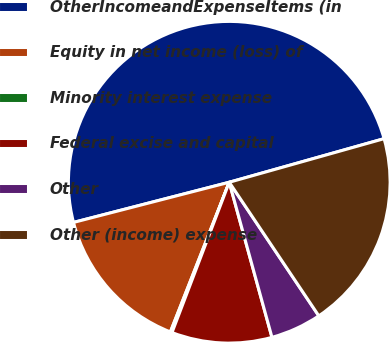<chart> <loc_0><loc_0><loc_500><loc_500><pie_chart><fcel>OtherIncomeandExpenseItems (in<fcel>Equity in net income (loss) of<fcel>Minority interest expense<fcel>Federal excise and capital<fcel>Other<fcel>Other (income) expense<nl><fcel>49.65%<fcel>15.02%<fcel>0.17%<fcel>10.07%<fcel>5.12%<fcel>19.97%<nl></chart> 